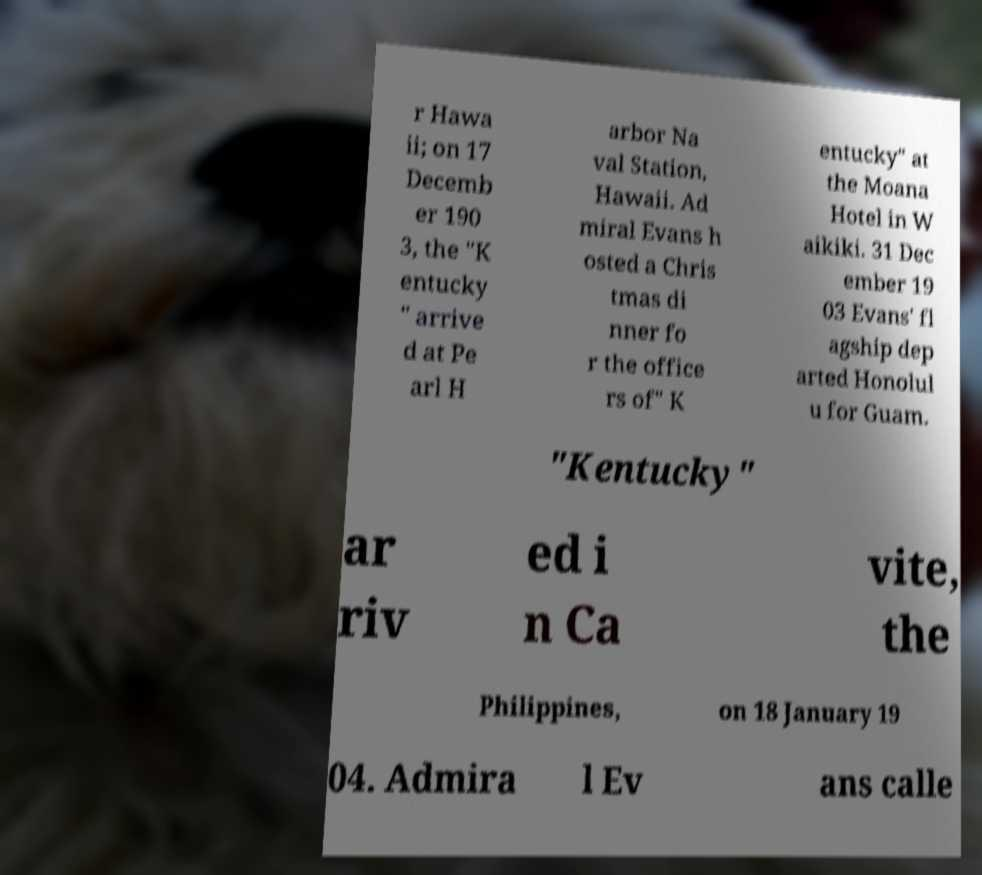There's text embedded in this image that I need extracted. Can you transcribe it verbatim? r Hawa ii; on 17 Decemb er 190 3, the "K entucky " arrive d at Pe arl H arbor Na val Station, Hawaii. Ad miral Evans h osted a Chris tmas di nner fo r the office rs of" K entucky" at the Moana Hotel in W aikiki. 31 Dec ember 19 03 Evans' fl agship dep arted Honolul u for Guam. "Kentucky" ar riv ed i n Ca vite, the Philippines, on 18 January 19 04. Admira l Ev ans calle 